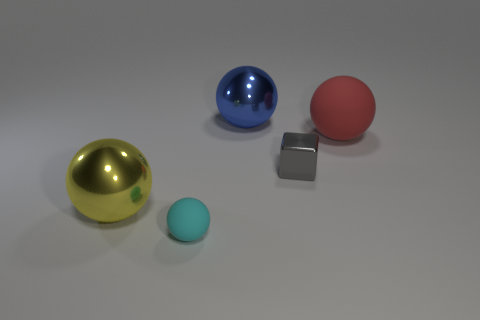The big yellow metallic thing is what shape?
Make the answer very short. Sphere. The big ball to the left of the matte sphere that is in front of the yellow metal ball is what color?
Ensure brevity in your answer.  Yellow. There is a rubber ball left of the tiny gray metal cube; what is its size?
Your response must be concise. Small. Are there any objects that have the same material as the tiny cyan ball?
Offer a terse response. Yes. How many other small objects have the same shape as the blue object?
Offer a terse response. 1. The large metal thing that is behind the large ball to the left of the matte ball that is left of the gray shiny cube is what shape?
Your answer should be compact. Sphere. There is a large thing that is both to the left of the big matte ball and on the right side of the big yellow ball; what material is it?
Provide a succinct answer. Metal. There is a rubber thing left of the red matte ball; does it have the same size as the large blue metallic ball?
Make the answer very short. No. Is the number of matte objects that are to the right of the blue metal object greater than the number of large blue spheres on the right side of the tiny gray metallic thing?
Offer a terse response. Yes. There is a matte thing in front of the large metal thing on the left side of the rubber sphere left of the large red thing; what color is it?
Make the answer very short. Cyan. 